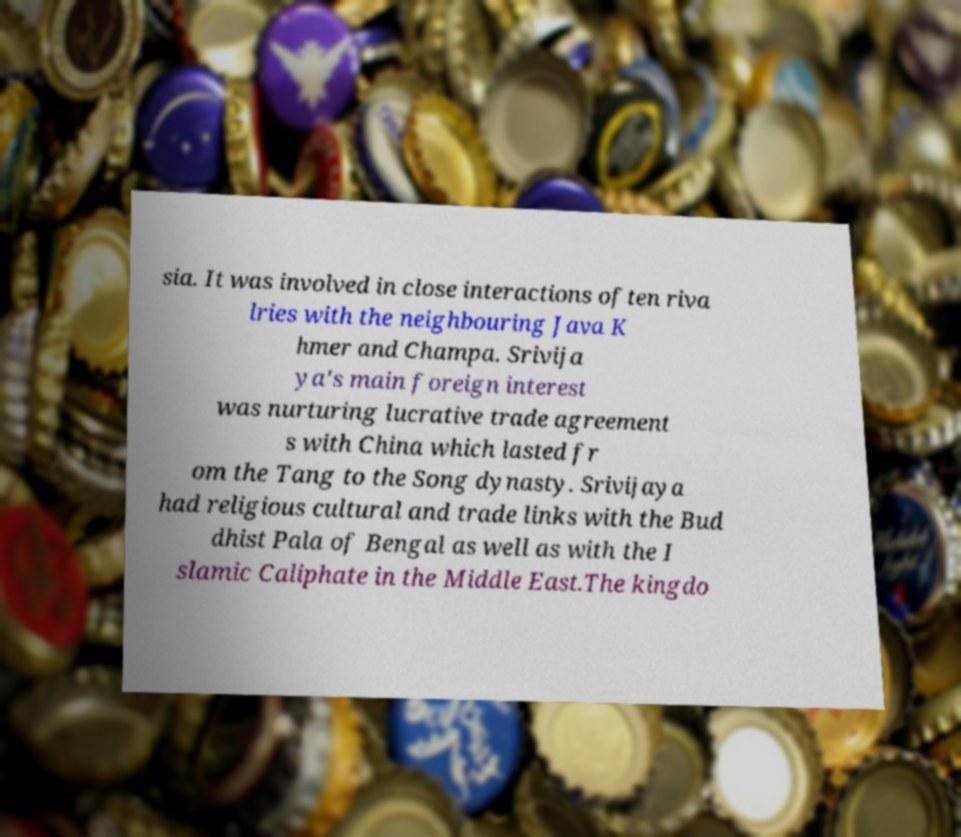There's text embedded in this image that I need extracted. Can you transcribe it verbatim? sia. It was involved in close interactions often riva lries with the neighbouring Java K hmer and Champa. Srivija ya's main foreign interest was nurturing lucrative trade agreement s with China which lasted fr om the Tang to the Song dynasty. Srivijaya had religious cultural and trade links with the Bud dhist Pala of Bengal as well as with the I slamic Caliphate in the Middle East.The kingdo 